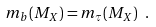Convert formula to latex. <formula><loc_0><loc_0><loc_500><loc_500>m _ { b } ( M _ { X } ) = m _ { \tau } ( M _ { X } ) \ .</formula> 